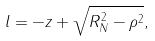<formula> <loc_0><loc_0><loc_500><loc_500>l = - z + \sqrt { R _ { N } ^ { 2 } - \rho ^ { 2 } } ,</formula> 